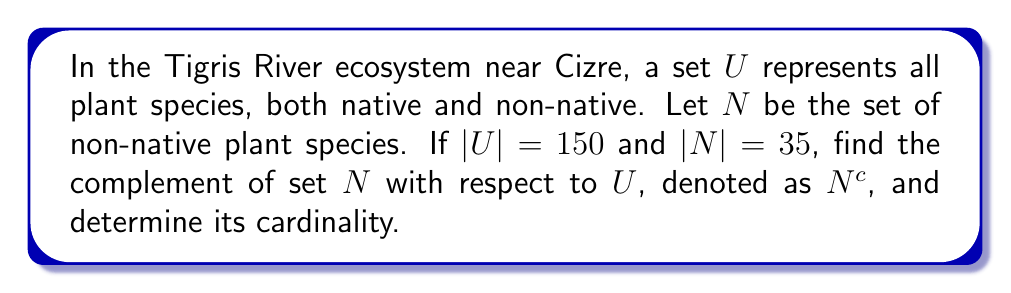Can you answer this question? To solve this problem, let's follow these steps:

1) First, recall that the complement of a set $A$ with respect to a universal set $U$ is defined as all elements in $U$ that are not in $A$. In set notation, this is written as:

   $A^c = U \setminus A = \{x \in U : x \notin A\}$

2) In our case, $N^c$ represents all plant species in the Tigris River ecosystem that are native (i.e., not non-native).

3) To find the cardinality of $N^c$, we can use the relationship between a set and its complement:

   $|U| = |N| + |N^c|$

4) We are given that $|U| = 150$ and $|N| = 35$. Let's substitute these values:

   $150 = 35 + |N^c|$

5) Solving for $|N^c|$:

   $|N^c| = 150 - 35 = 115$

Therefore, the complement of set $N$ (non-native plants) contains 115 elements, which represents the number of native plant species in the Tigris River ecosystem near Cizre.
Answer: $N^c = \{x \in U : x \notin N\}$, where $|N^c| = 115$ 